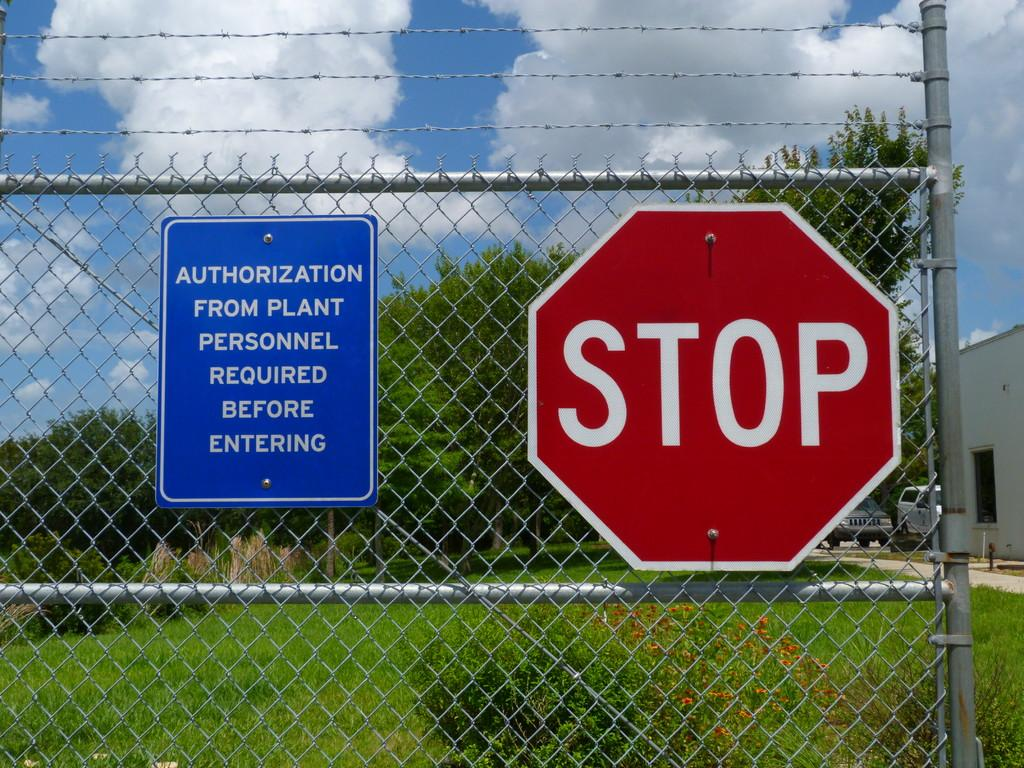<image>
Relay a brief, clear account of the picture shown. A gate that states that one must get authorization before entering. 